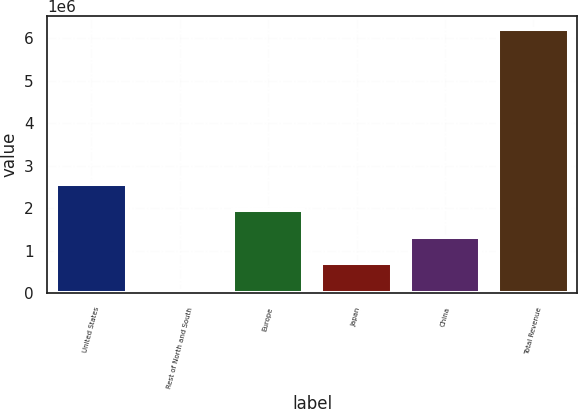Convert chart. <chart><loc_0><loc_0><loc_500><loc_500><bar_chart><fcel>United States<fcel>Rest of North and South<fcel>Europe<fcel>Japan<fcel>China<fcel>Total Revenue<nl><fcel>2.56837e+06<fcel>46276<fcel>1.95053e+06<fcel>714846<fcel>1.33269e+06<fcel>6.22469e+06<nl></chart> 